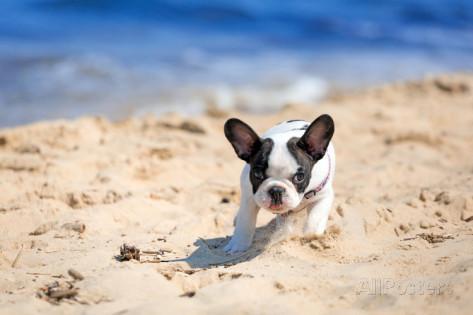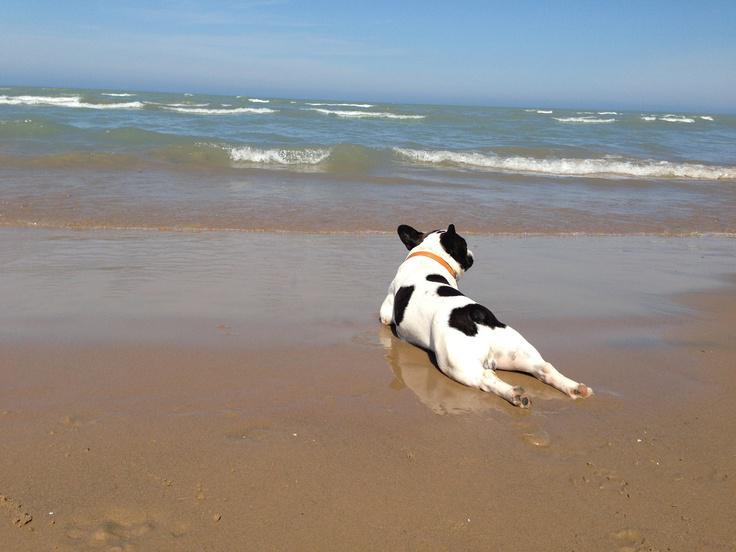The first image is the image on the left, the second image is the image on the right. Considering the images on both sides, is "An image shows a brownish dog in profile, wearing a harness." valid? Answer yes or no. No. 